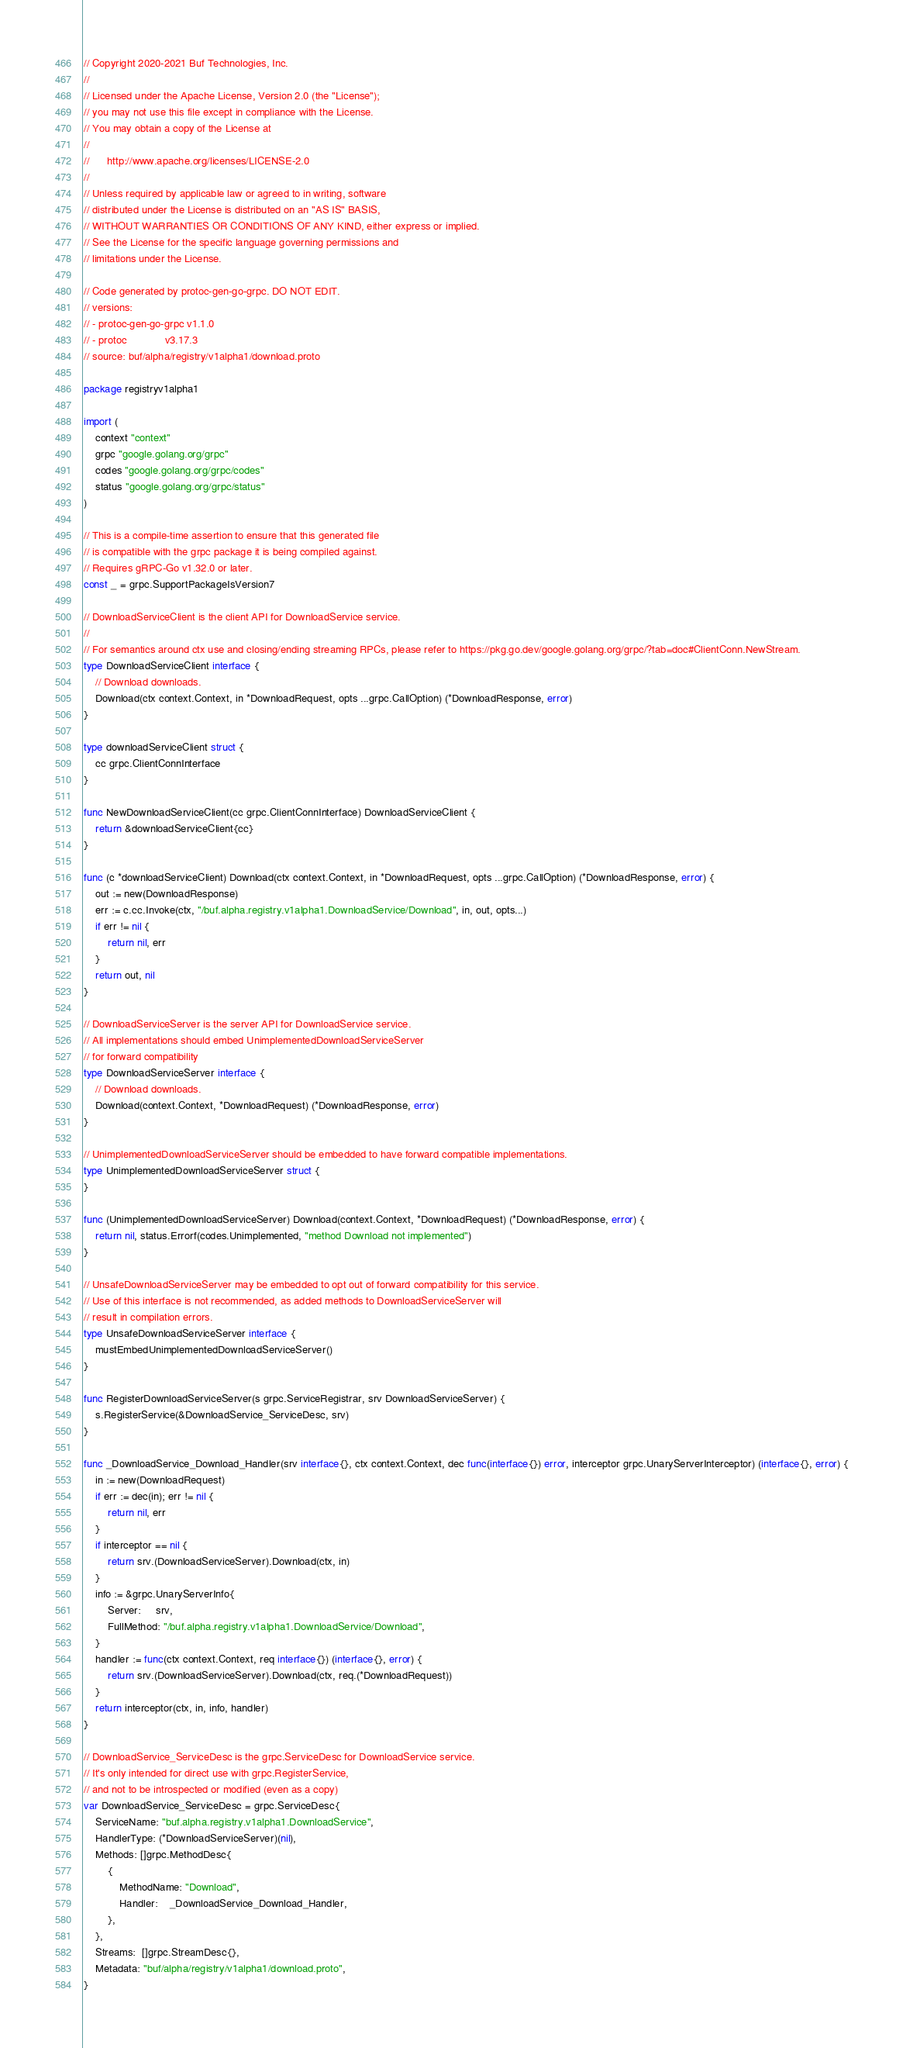Convert code to text. <code><loc_0><loc_0><loc_500><loc_500><_Go_>// Copyright 2020-2021 Buf Technologies, Inc.
//
// Licensed under the Apache License, Version 2.0 (the "License");
// you may not use this file except in compliance with the License.
// You may obtain a copy of the License at
//
//      http://www.apache.org/licenses/LICENSE-2.0
//
// Unless required by applicable law or agreed to in writing, software
// distributed under the License is distributed on an "AS IS" BASIS,
// WITHOUT WARRANTIES OR CONDITIONS OF ANY KIND, either express or implied.
// See the License for the specific language governing permissions and
// limitations under the License.

// Code generated by protoc-gen-go-grpc. DO NOT EDIT.
// versions:
// - protoc-gen-go-grpc v1.1.0
// - protoc             v3.17.3
// source: buf/alpha/registry/v1alpha1/download.proto

package registryv1alpha1

import (
	context "context"
	grpc "google.golang.org/grpc"
	codes "google.golang.org/grpc/codes"
	status "google.golang.org/grpc/status"
)

// This is a compile-time assertion to ensure that this generated file
// is compatible with the grpc package it is being compiled against.
// Requires gRPC-Go v1.32.0 or later.
const _ = grpc.SupportPackageIsVersion7

// DownloadServiceClient is the client API for DownloadService service.
//
// For semantics around ctx use and closing/ending streaming RPCs, please refer to https://pkg.go.dev/google.golang.org/grpc/?tab=doc#ClientConn.NewStream.
type DownloadServiceClient interface {
	// Download downloads.
	Download(ctx context.Context, in *DownloadRequest, opts ...grpc.CallOption) (*DownloadResponse, error)
}

type downloadServiceClient struct {
	cc grpc.ClientConnInterface
}

func NewDownloadServiceClient(cc grpc.ClientConnInterface) DownloadServiceClient {
	return &downloadServiceClient{cc}
}

func (c *downloadServiceClient) Download(ctx context.Context, in *DownloadRequest, opts ...grpc.CallOption) (*DownloadResponse, error) {
	out := new(DownloadResponse)
	err := c.cc.Invoke(ctx, "/buf.alpha.registry.v1alpha1.DownloadService/Download", in, out, opts...)
	if err != nil {
		return nil, err
	}
	return out, nil
}

// DownloadServiceServer is the server API for DownloadService service.
// All implementations should embed UnimplementedDownloadServiceServer
// for forward compatibility
type DownloadServiceServer interface {
	// Download downloads.
	Download(context.Context, *DownloadRequest) (*DownloadResponse, error)
}

// UnimplementedDownloadServiceServer should be embedded to have forward compatible implementations.
type UnimplementedDownloadServiceServer struct {
}

func (UnimplementedDownloadServiceServer) Download(context.Context, *DownloadRequest) (*DownloadResponse, error) {
	return nil, status.Errorf(codes.Unimplemented, "method Download not implemented")
}

// UnsafeDownloadServiceServer may be embedded to opt out of forward compatibility for this service.
// Use of this interface is not recommended, as added methods to DownloadServiceServer will
// result in compilation errors.
type UnsafeDownloadServiceServer interface {
	mustEmbedUnimplementedDownloadServiceServer()
}

func RegisterDownloadServiceServer(s grpc.ServiceRegistrar, srv DownloadServiceServer) {
	s.RegisterService(&DownloadService_ServiceDesc, srv)
}

func _DownloadService_Download_Handler(srv interface{}, ctx context.Context, dec func(interface{}) error, interceptor grpc.UnaryServerInterceptor) (interface{}, error) {
	in := new(DownloadRequest)
	if err := dec(in); err != nil {
		return nil, err
	}
	if interceptor == nil {
		return srv.(DownloadServiceServer).Download(ctx, in)
	}
	info := &grpc.UnaryServerInfo{
		Server:     srv,
		FullMethod: "/buf.alpha.registry.v1alpha1.DownloadService/Download",
	}
	handler := func(ctx context.Context, req interface{}) (interface{}, error) {
		return srv.(DownloadServiceServer).Download(ctx, req.(*DownloadRequest))
	}
	return interceptor(ctx, in, info, handler)
}

// DownloadService_ServiceDesc is the grpc.ServiceDesc for DownloadService service.
// It's only intended for direct use with grpc.RegisterService,
// and not to be introspected or modified (even as a copy)
var DownloadService_ServiceDesc = grpc.ServiceDesc{
	ServiceName: "buf.alpha.registry.v1alpha1.DownloadService",
	HandlerType: (*DownloadServiceServer)(nil),
	Methods: []grpc.MethodDesc{
		{
			MethodName: "Download",
			Handler:    _DownloadService_Download_Handler,
		},
	},
	Streams:  []grpc.StreamDesc{},
	Metadata: "buf/alpha/registry/v1alpha1/download.proto",
}
</code> 